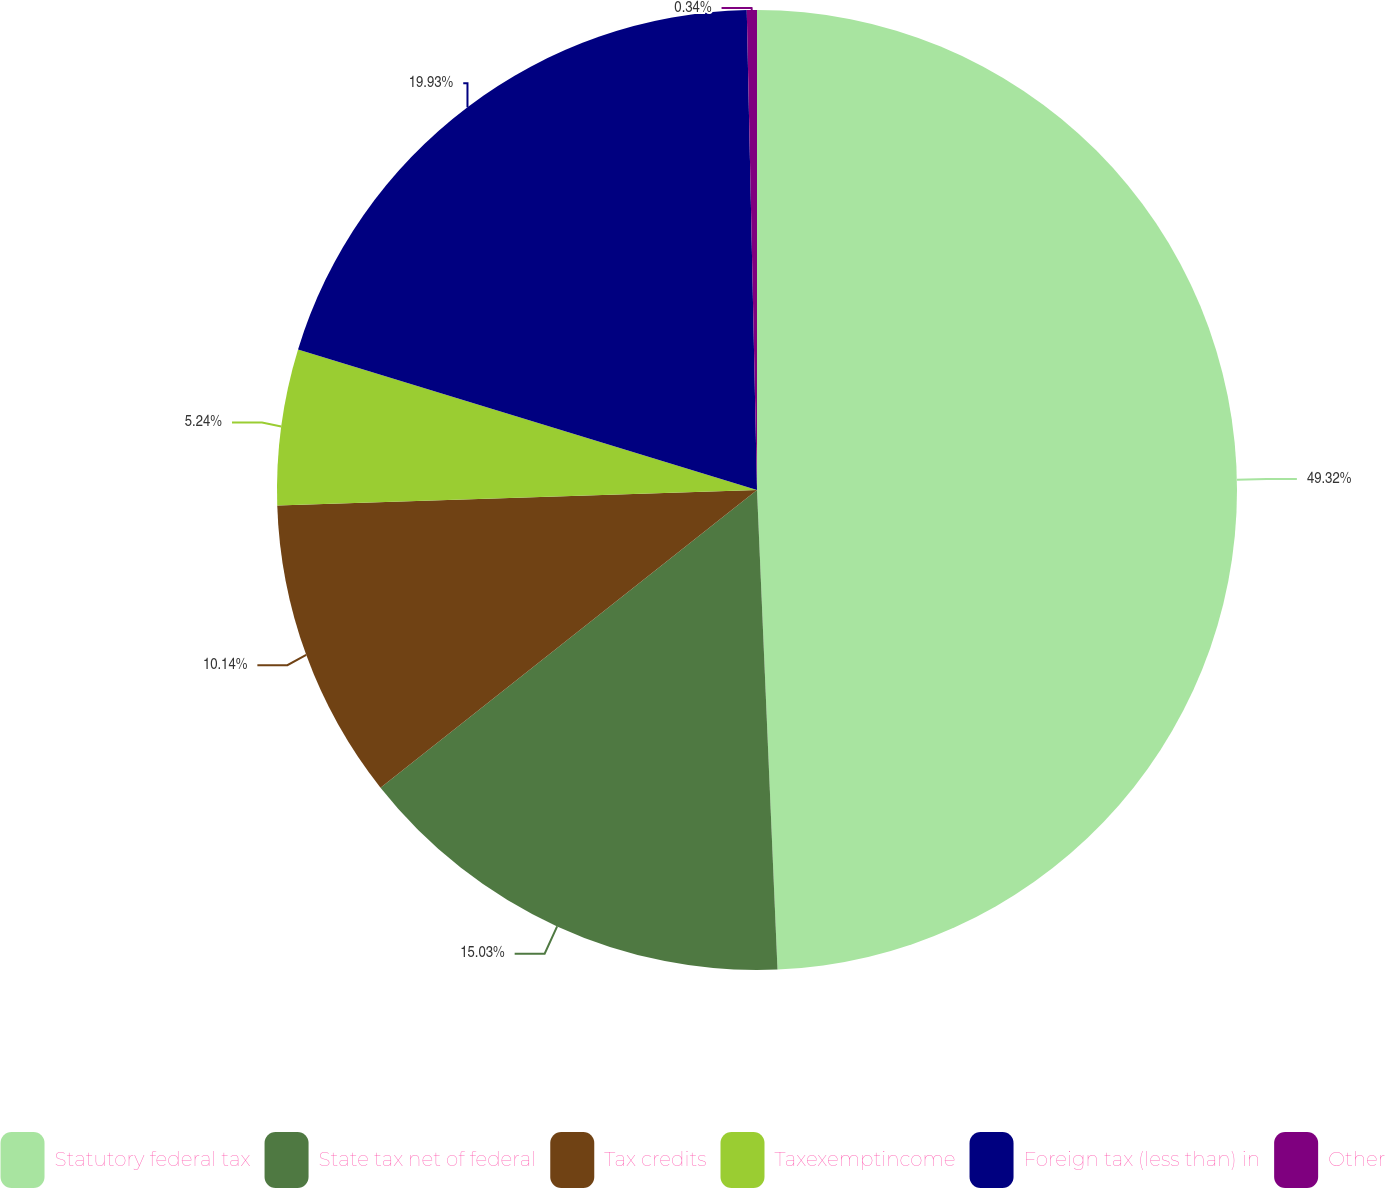Convert chart. <chart><loc_0><loc_0><loc_500><loc_500><pie_chart><fcel>Statutory federal tax<fcel>State tax net of federal<fcel>Tax credits<fcel>Taxexemptincome<fcel>Foreign tax (less than) in<fcel>Other<nl><fcel>49.32%<fcel>15.03%<fcel>10.14%<fcel>5.24%<fcel>19.93%<fcel>0.34%<nl></chart> 